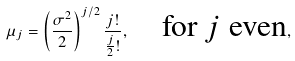Convert formula to latex. <formula><loc_0><loc_0><loc_500><loc_500>\mu _ { j } = \left ( \frac { \sigma ^ { 2 } } { 2 } \right ) ^ { j / 2 } \frac { j ! } { \frac { j } { 2 } ! } , \quad \text {for $j$ even} ,</formula> 